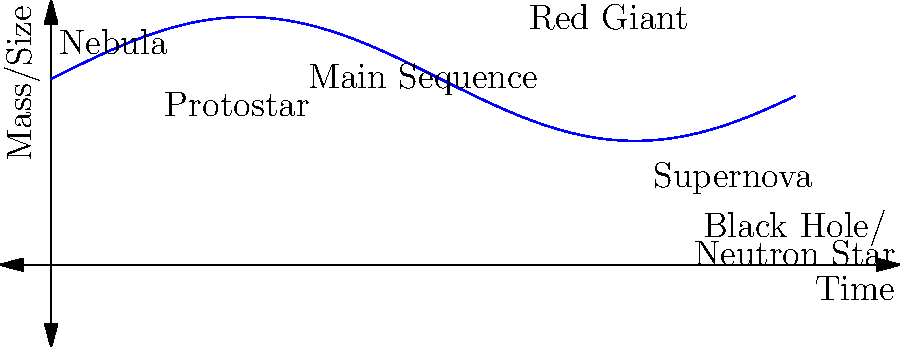In the life cycle of a massive star, which stage immediately precedes the formation of a black hole or neutron star? To understand the life cycle of a massive star, let's break it down step-by-step:

1. Nebula: The star's life begins as a cloud of gas and dust.
2. Protostar: Gravity causes the nebula to collapse, forming a protostar.
3. Main Sequence: Nuclear fusion begins, and the star spends most of its life in this stage.
4. Red Giant: As hydrogen fuel depletes, the core contracts and the outer layers expand.
5. Supernova: For massive stars, the core collapses, triggering a violent explosion.
6. Black Hole or Neutron Star: The remnant of the supernova becomes either a black hole or neutron star, depending on the initial mass of the star.

The stage immediately before a black hole or neutron star is the supernova. This explosive event marks the end of the star's life and leads to the formation of these incredibly dense objects.

For patients dealing with serious diagnoses, understanding the life cycles of stars can provide a perspective on the natural processes of transformation and the interconnectedness of all matter in the universe.
Answer: Supernova 